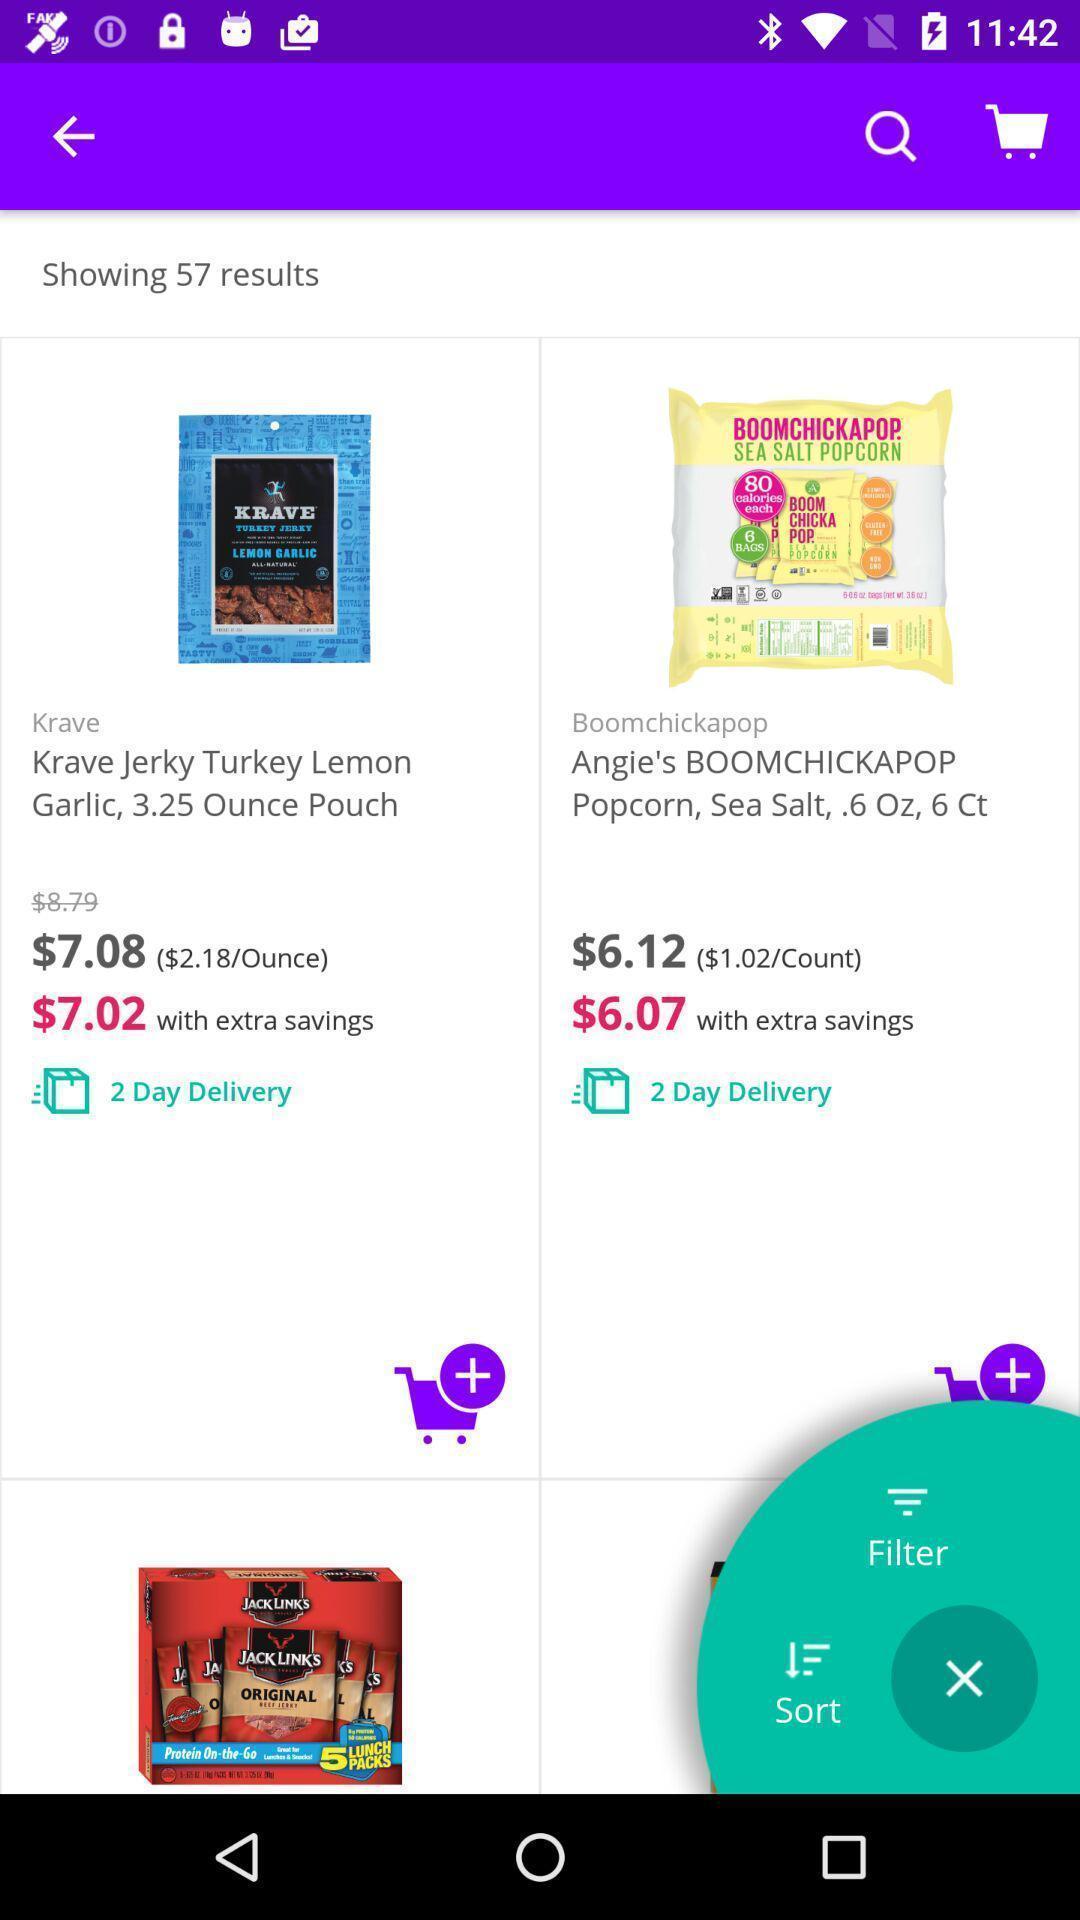Describe the key features of this screenshot. Screen shows multiple products in a shopping application. 